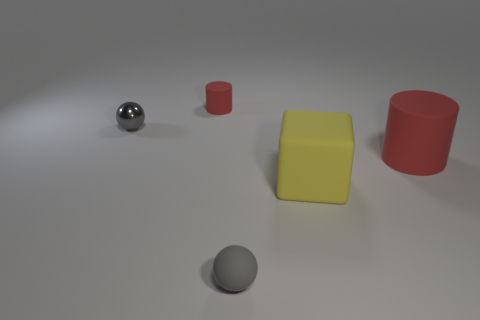Add 2 purple cylinders. How many objects exist? 7 Subtract all cubes. How many objects are left? 4 Add 5 matte objects. How many matte objects are left? 9 Add 5 rubber objects. How many rubber objects exist? 9 Subtract 0 blue cylinders. How many objects are left? 5 Subtract all cyan matte cylinders. Subtract all gray spheres. How many objects are left? 3 